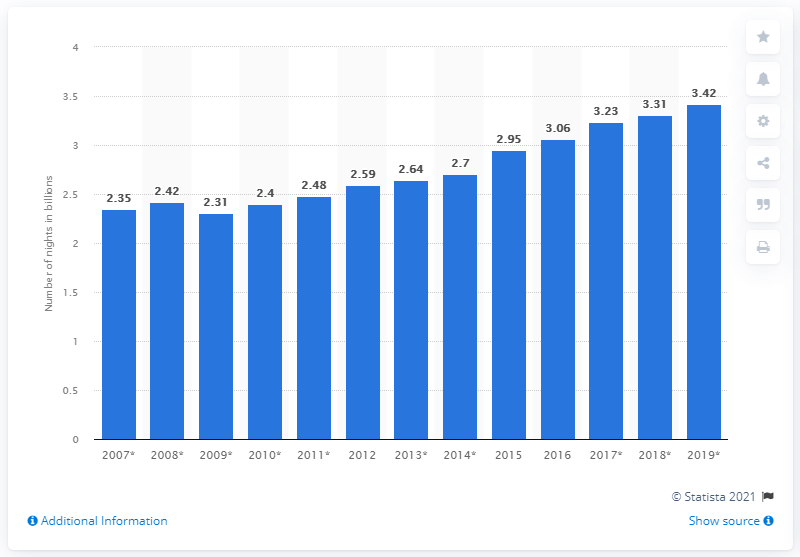Indicate a few pertinent items in this graphic. In 2019, a total of 3.42 nights were spent on travel accommodations in the European Union. 